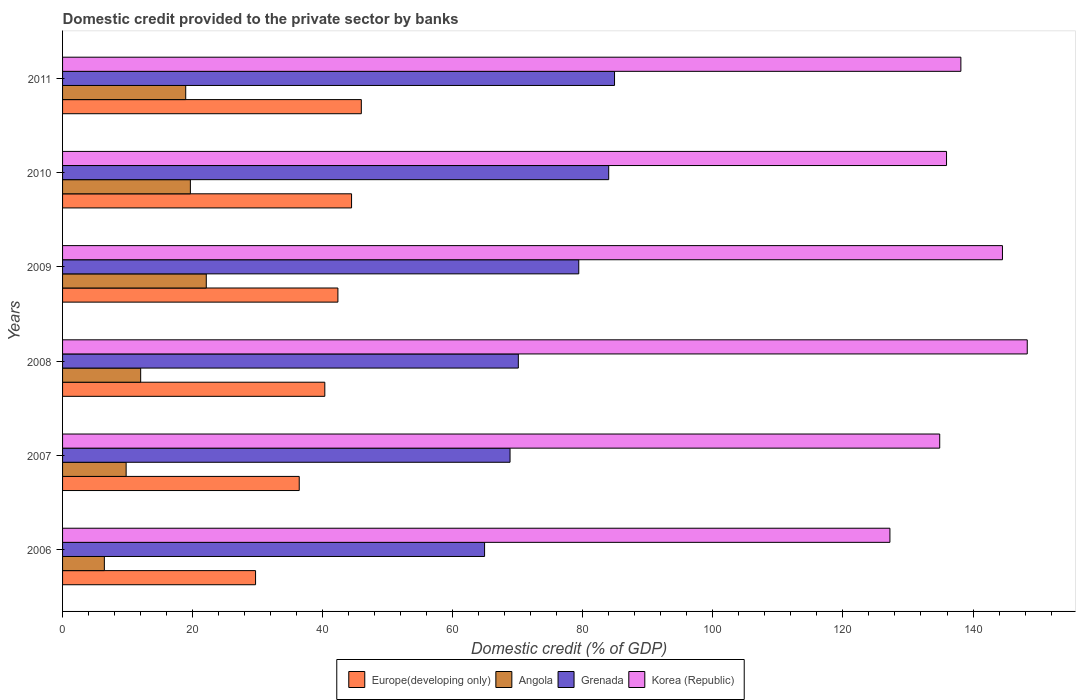How many different coloured bars are there?
Ensure brevity in your answer.  4. How many groups of bars are there?
Provide a succinct answer. 6. Are the number of bars per tick equal to the number of legend labels?
Your answer should be compact. Yes. How many bars are there on the 5th tick from the bottom?
Offer a very short reply. 4. What is the domestic credit provided to the private sector by banks in Korea (Republic) in 2006?
Provide a short and direct response. 127.22. Across all years, what is the maximum domestic credit provided to the private sector by banks in Grenada?
Provide a succinct answer. 84.88. Across all years, what is the minimum domestic credit provided to the private sector by banks in Europe(developing only)?
Your answer should be very brief. 29.68. In which year was the domestic credit provided to the private sector by banks in Korea (Republic) minimum?
Provide a short and direct response. 2006. What is the total domestic credit provided to the private sector by banks in Korea (Republic) in the graph?
Provide a short and direct response. 829.03. What is the difference between the domestic credit provided to the private sector by banks in Korea (Republic) in 2010 and that in 2011?
Your response must be concise. -2.21. What is the difference between the domestic credit provided to the private sector by banks in Grenada in 2010 and the domestic credit provided to the private sector by banks in Europe(developing only) in 2007?
Keep it short and to the point. 47.59. What is the average domestic credit provided to the private sector by banks in Korea (Republic) per year?
Give a very brief answer. 138.17. In the year 2007, what is the difference between the domestic credit provided to the private sector by banks in Korea (Republic) and domestic credit provided to the private sector by banks in Grenada?
Offer a very short reply. 66.07. What is the ratio of the domestic credit provided to the private sector by banks in Korea (Republic) in 2006 to that in 2007?
Give a very brief answer. 0.94. Is the difference between the domestic credit provided to the private sector by banks in Korea (Republic) in 2006 and 2008 greater than the difference between the domestic credit provided to the private sector by banks in Grenada in 2006 and 2008?
Provide a succinct answer. No. What is the difference between the highest and the second highest domestic credit provided to the private sector by banks in Angola?
Provide a short and direct response. 2.45. What is the difference between the highest and the lowest domestic credit provided to the private sector by banks in Angola?
Keep it short and to the point. 15.67. Is it the case that in every year, the sum of the domestic credit provided to the private sector by banks in Angola and domestic credit provided to the private sector by banks in Grenada is greater than the sum of domestic credit provided to the private sector by banks in Korea (Republic) and domestic credit provided to the private sector by banks in Europe(developing only)?
Your answer should be compact. No. What does the 2nd bar from the top in 2010 represents?
Your answer should be compact. Grenada. What does the 4th bar from the bottom in 2011 represents?
Offer a terse response. Korea (Republic). Is it the case that in every year, the sum of the domestic credit provided to the private sector by banks in Europe(developing only) and domestic credit provided to the private sector by banks in Angola is greater than the domestic credit provided to the private sector by banks in Korea (Republic)?
Give a very brief answer. No. How many bars are there?
Offer a very short reply. 24. How many years are there in the graph?
Provide a succinct answer. 6. What is the difference between two consecutive major ticks on the X-axis?
Offer a terse response. 20. Are the values on the major ticks of X-axis written in scientific E-notation?
Give a very brief answer. No. Does the graph contain any zero values?
Offer a very short reply. No. How many legend labels are there?
Give a very brief answer. 4. How are the legend labels stacked?
Offer a very short reply. Horizontal. What is the title of the graph?
Make the answer very short. Domestic credit provided to the private sector by banks. Does "Cote d'Ivoire" appear as one of the legend labels in the graph?
Your answer should be very brief. No. What is the label or title of the X-axis?
Make the answer very short. Domestic credit (% of GDP). What is the label or title of the Y-axis?
Offer a very short reply. Years. What is the Domestic credit (% of GDP) of Europe(developing only) in 2006?
Your answer should be compact. 29.68. What is the Domestic credit (% of GDP) of Angola in 2006?
Give a very brief answer. 6.43. What is the Domestic credit (% of GDP) of Grenada in 2006?
Your answer should be compact. 64.89. What is the Domestic credit (% of GDP) of Korea (Republic) in 2006?
Your answer should be very brief. 127.22. What is the Domestic credit (% of GDP) in Europe(developing only) in 2007?
Provide a short and direct response. 36.39. What is the Domestic credit (% of GDP) of Angola in 2007?
Offer a terse response. 9.77. What is the Domestic credit (% of GDP) of Grenada in 2007?
Provide a short and direct response. 68.81. What is the Domestic credit (% of GDP) in Korea (Republic) in 2007?
Make the answer very short. 134.88. What is the Domestic credit (% of GDP) of Europe(developing only) in 2008?
Provide a succinct answer. 40.32. What is the Domestic credit (% of GDP) in Angola in 2008?
Your answer should be very brief. 12.01. What is the Domestic credit (% of GDP) of Grenada in 2008?
Ensure brevity in your answer.  70.08. What is the Domestic credit (% of GDP) in Korea (Republic) in 2008?
Offer a very short reply. 148.34. What is the Domestic credit (% of GDP) in Europe(developing only) in 2009?
Offer a very short reply. 42.34. What is the Domestic credit (% of GDP) of Angola in 2009?
Give a very brief answer. 22.1. What is the Domestic credit (% of GDP) in Grenada in 2009?
Your response must be concise. 79.38. What is the Domestic credit (% of GDP) of Korea (Republic) in 2009?
Your answer should be compact. 144.53. What is the Domestic credit (% of GDP) of Europe(developing only) in 2010?
Give a very brief answer. 44.44. What is the Domestic credit (% of GDP) in Angola in 2010?
Ensure brevity in your answer.  19.65. What is the Domestic credit (% of GDP) in Grenada in 2010?
Your answer should be very brief. 83.98. What is the Domestic credit (% of GDP) of Korea (Republic) in 2010?
Offer a very short reply. 135.93. What is the Domestic credit (% of GDP) of Europe(developing only) in 2011?
Offer a very short reply. 45.94. What is the Domestic credit (% of GDP) of Angola in 2011?
Your response must be concise. 18.94. What is the Domestic credit (% of GDP) of Grenada in 2011?
Provide a succinct answer. 84.88. What is the Domestic credit (% of GDP) of Korea (Republic) in 2011?
Provide a short and direct response. 138.13. Across all years, what is the maximum Domestic credit (% of GDP) in Europe(developing only)?
Your response must be concise. 45.94. Across all years, what is the maximum Domestic credit (% of GDP) in Angola?
Your answer should be very brief. 22.1. Across all years, what is the maximum Domestic credit (% of GDP) in Grenada?
Your response must be concise. 84.88. Across all years, what is the maximum Domestic credit (% of GDP) of Korea (Republic)?
Give a very brief answer. 148.34. Across all years, what is the minimum Domestic credit (% of GDP) in Europe(developing only)?
Keep it short and to the point. 29.68. Across all years, what is the minimum Domestic credit (% of GDP) of Angola?
Your answer should be very brief. 6.43. Across all years, what is the minimum Domestic credit (% of GDP) in Grenada?
Keep it short and to the point. 64.89. Across all years, what is the minimum Domestic credit (% of GDP) of Korea (Republic)?
Make the answer very short. 127.22. What is the total Domestic credit (% of GDP) of Europe(developing only) in the graph?
Ensure brevity in your answer.  239.11. What is the total Domestic credit (% of GDP) in Angola in the graph?
Your answer should be compact. 88.9. What is the total Domestic credit (% of GDP) of Grenada in the graph?
Offer a terse response. 452.02. What is the total Domestic credit (% of GDP) of Korea (Republic) in the graph?
Your response must be concise. 829.03. What is the difference between the Domestic credit (% of GDP) of Europe(developing only) in 2006 and that in 2007?
Keep it short and to the point. -6.72. What is the difference between the Domestic credit (% of GDP) of Angola in 2006 and that in 2007?
Keep it short and to the point. -3.35. What is the difference between the Domestic credit (% of GDP) of Grenada in 2006 and that in 2007?
Offer a terse response. -3.91. What is the difference between the Domestic credit (% of GDP) of Korea (Republic) in 2006 and that in 2007?
Give a very brief answer. -7.66. What is the difference between the Domestic credit (% of GDP) in Europe(developing only) in 2006 and that in 2008?
Provide a short and direct response. -10.65. What is the difference between the Domestic credit (% of GDP) in Angola in 2006 and that in 2008?
Your answer should be compact. -5.58. What is the difference between the Domestic credit (% of GDP) of Grenada in 2006 and that in 2008?
Offer a very short reply. -5.19. What is the difference between the Domestic credit (% of GDP) in Korea (Republic) in 2006 and that in 2008?
Offer a terse response. -21.12. What is the difference between the Domestic credit (% of GDP) in Europe(developing only) in 2006 and that in 2009?
Your answer should be very brief. -12.66. What is the difference between the Domestic credit (% of GDP) of Angola in 2006 and that in 2009?
Your answer should be very brief. -15.67. What is the difference between the Domestic credit (% of GDP) in Grenada in 2006 and that in 2009?
Provide a succinct answer. -14.48. What is the difference between the Domestic credit (% of GDP) of Korea (Republic) in 2006 and that in 2009?
Make the answer very short. -17.31. What is the difference between the Domestic credit (% of GDP) of Europe(developing only) in 2006 and that in 2010?
Your answer should be compact. -14.76. What is the difference between the Domestic credit (% of GDP) in Angola in 2006 and that in 2010?
Provide a short and direct response. -13.23. What is the difference between the Domestic credit (% of GDP) in Grenada in 2006 and that in 2010?
Keep it short and to the point. -19.09. What is the difference between the Domestic credit (% of GDP) of Korea (Republic) in 2006 and that in 2010?
Offer a terse response. -8.71. What is the difference between the Domestic credit (% of GDP) of Europe(developing only) in 2006 and that in 2011?
Make the answer very short. -16.26. What is the difference between the Domestic credit (% of GDP) of Angola in 2006 and that in 2011?
Provide a short and direct response. -12.51. What is the difference between the Domestic credit (% of GDP) in Grenada in 2006 and that in 2011?
Make the answer very short. -19.98. What is the difference between the Domestic credit (% of GDP) in Korea (Republic) in 2006 and that in 2011?
Give a very brief answer. -10.91. What is the difference between the Domestic credit (% of GDP) of Europe(developing only) in 2007 and that in 2008?
Your answer should be very brief. -3.93. What is the difference between the Domestic credit (% of GDP) of Angola in 2007 and that in 2008?
Provide a succinct answer. -2.24. What is the difference between the Domestic credit (% of GDP) in Grenada in 2007 and that in 2008?
Your response must be concise. -1.27. What is the difference between the Domestic credit (% of GDP) in Korea (Republic) in 2007 and that in 2008?
Your answer should be very brief. -13.46. What is the difference between the Domestic credit (% of GDP) of Europe(developing only) in 2007 and that in 2009?
Keep it short and to the point. -5.95. What is the difference between the Domestic credit (% of GDP) in Angola in 2007 and that in 2009?
Your answer should be very brief. -12.32. What is the difference between the Domestic credit (% of GDP) in Grenada in 2007 and that in 2009?
Your answer should be very brief. -10.57. What is the difference between the Domestic credit (% of GDP) in Korea (Republic) in 2007 and that in 2009?
Your answer should be very brief. -9.65. What is the difference between the Domestic credit (% of GDP) in Europe(developing only) in 2007 and that in 2010?
Make the answer very short. -8.04. What is the difference between the Domestic credit (% of GDP) in Angola in 2007 and that in 2010?
Ensure brevity in your answer.  -9.88. What is the difference between the Domestic credit (% of GDP) of Grenada in 2007 and that in 2010?
Offer a very short reply. -15.17. What is the difference between the Domestic credit (% of GDP) in Korea (Republic) in 2007 and that in 2010?
Your response must be concise. -1.05. What is the difference between the Domestic credit (% of GDP) in Europe(developing only) in 2007 and that in 2011?
Offer a terse response. -9.55. What is the difference between the Domestic credit (% of GDP) of Angola in 2007 and that in 2011?
Your response must be concise. -9.16. What is the difference between the Domestic credit (% of GDP) in Grenada in 2007 and that in 2011?
Make the answer very short. -16.07. What is the difference between the Domestic credit (% of GDP) of Korea (Republic) in 2007 and that in 2011?
Offer a very short reply. -3.25. What is the difference between the Domestic credit (% of GDP) in Europe(developing only) in 2008 and that in 2009?
Provide a short and direct response. -2.01. What is the difference between the Domestic credit (% of GDP) in Angola in 2008 and that in 2009?
Give a very brief answer. -10.09. What is the difference between the Domestic credit (% of GDP) of Grenada in 2008 and that in 2009?
Provide a short and direct response. -9.3. What is the difference between the Domestic credit (% of GDP) in Korea (Republic) in 2008 and that in 2009?
Provide a short and direct response. 3.81. What is the difference between the Domestic credit (% of GDP) in Europe(developing only) in 2008 and that in 2010?
Your answer should be compact. -4.11. What is the difference between the Domestic credit (% of GDP) in Angola in 2008 and that in 2010?
Offer a terse response. -7.64. What is the difference between the Domestic credit (% of GDP) in Grenada in 2008 and that in 2010?
Ensure brevity in your answer.  -13.9. What is the difference between the Domestic credit (% of GDP) in Korea (Republic) in 2008 and that in 2010?
Offer a terse response. 12.41. What is the difference between the Domestic credit (% of GDP) of Europe(developing only) in 2008 and that in 2011?
Ensure brevity in your answer.  -5.62. What is the difference between the Domestic credit (% of GDP) in Angola in 2008 and that in 2011?
Your response must be concise. -6.93. What is the difference between the Domestic credit (% of GDP) in Grenada in 2008 and that in 2011?
Your answer should be compact. -14.8. What is the difference between the Domestic credit (% of GDP) of Korea (Republic) in 2008 and that in 2011?
Your response must be concise. 10.21. What is the difference between the Domestic credit (% of GDP) of Europe(developing only) in 2009 and that in 2010?
Keep it short and to the point. -2.1. What is the difference between the Domestic credit (% of GDP) in Angola in 2009 and that in 2010?
Provide a succinct answer. 2.45. What is the difference between the Domestic credit (% of GDP) in Grenada in 2009 and that in 2010?
Give a very brief answer. -4.6. What is the difference between the Domestic credit (% of GDP) in Korea (Republic) in 2009 and that in 2010?
Make the answer very short. 8.6. What is the difference between the Domestic credit (% of GDP) of Europe(developing only) in 2009 and that in 2011?
Make the answer very short. -3.6. What is the difference between the Domestic credit (% of GDP) of Angola in 2009 and that in 2011?
Offer a terse response. 3.16. What is the difference between the Domestic credit (% of GDP) in Grenada in 2009 and that in 2011?
Your answer should be compact. -5.5. What is the difference between the Domestic credit (% of GDP) in Korea (Republic) in 2009 and that in 2011?
Make the answer very short. 6.39. What is the difference between the Domestic credit (% of GDP) of Europe(developing only) in 2010 and that in 2011?
Your answer should be very brief. -1.5. What is the difference between the Domestic credit (% of GDP) of Angola in 2010 and that in 2011?
Offer a terse response. 0.72. What is the difference between the Domestic credit (% of GDP) of Grenada in 2010 and that in 2011?
Make the answer very short. -0.9. What is the difference between the Domestic credit (% of GDP) in Korea (Republic) in 2010 and that in 2011?
Offer a terse response. -2.21. What is the difference between the Domestic credit (% of GDP) of Europe(developing only) in 2006 and the Domestic credit (% of GDP) of Angola in 2007?
Your answer should be very brief. 19.9. What is the difference between the Domestic credit (% of GDP) in Europe(developing only) in 2006 and the Domestic credit (% of GDP) in Grenada in 2007?
Your response must be concise. -39.13. What is the difference between the Domestic credit (% of GDP) of Europe(developing only) in 2006 and the Domestic credit (% of GDP) of Korea (Republic) in 2007?
Provide a short and direct response. -105.2. What is the difference between the Domestic credit (% of GDP) in Angola in 2006 and the Domestic credit (% of GDP) in Grenada in 2007?
Provide a short and direct response. -62.38. What is the difference between the Domestic credit (% of GDP) of Angola in 2006 and the Domestic credit (% of GDP) of Korea (Republic) in 2007?
Offer a terse response. -128.45. What is the difference between the Domestic credit (% of GDP) of Grenada in 2006 and the Domestic credit (% of GDP) of Korea (Republic) in 2007?
Offer a terse response. -69.99. What is the difference between the Domestic credit (% of GDP) of Europe(developing only) in 2006 and the Domestic credit (% of GDP) of Angola in 2008?
Ensure brevity in your answer.  17.67. What is the difference between the Domestic credit (% of GDP) in Europe(developing only) in 2006 and the Domestic credit (% of GDP) in Grenada in 2008?
Your answer should be very brief. -40.4. What is the difference between the Domestic credit (% of GDP) in Europe(developing only) in 2006 and the Domestic credit (% of GDP) in Korea (Republic) in 2008?
Your answer should be compact. -118.66. What is the difference between the Domestic credit (% of GDP) of Angola in 2006 and the Domestic credit (% of GDP) of Grenada in 2008?
Provide a short and direct response. -63.66. What is the difference between the Domestic credit (% of GDP) in Angola in 2006 and the Domestic credit (% of GDP) in Korea (Republic) in 2008?
Provide a succinct answer. -141.91. What is the difference between the Domestic credit (% of GDP) of Grenada in 2006 and the Domestic credit (% of GDP) of Korea (Republic) in 2008?
Keep it short and to the point. -83.45. What is the difference between the Domestic credit (% of GDP) of Europe(developing only) in 2006 and the Domestic credit (% of GDP) of Angola in 2009?
Make the answer very short. 7.58. What is the difference between the Domestic credit (% of GDP) of Europe(developing only) in 2006 and the Domestic credit (% of GDP) of Grenada in 2009?
Offer a very short reply. -49.7. What is the difference between the Domestic credit (% of GDP) of Europe(developing only) in 2006 and the Domestic credit (% of GDP) of Korea (Republic) in 2009?
Offer a very short reply. -114.85. What is the difference between the Domestic credit (% of GDP) of Angola in 2006 and the Domestic credit (% of GDP) of Grenada in 2009?
Provide a succinct answer. -72.95. What is the difference between the Domestic credit (% of GDP) of Angola in 2006 and the Domestic credit (% of GDP) of Korea (Republic) in 2009?
Offer a terse response. -138.1. What is the difference between the Domestic credit (% of GDP) of Grenada in 2006 and the Domestic credit (% of GDP) of Korea (Republic) in 2009?
Offer a terse response. -79.63. What is the difference between the Domestic credit (% of GDP) of Europe(developing only) in 2006 and the Domestic credit (% of GDP) of Angola in 2010?
Provide a short and direct response. 10.02. What is the difference between the Domestic credit (% of GDP) in Europe(developing only) in 2006 and the Domestic credit (% of GDP) in Grenada in 2010?
Your answer should be very brief. -54.3. What is the difference between the Domestic credit (% of GDP) in Europe(developing only) in 2006 and the Domestic credit (% of GDP) in Korea (Republic) in 2010?
Your response must be concise. -106.25. What is the difference between the Domestic credit (% of GDP) of Angola in 2006 and the Domestic credit (% of GDP) of Grenada in 2010?
Your answer should be compact. -77.55. What is the difference between the Domestic credit (% of GDP) in Angola in 2006 and the Domestic credit (% of GDP) in Korea (Republic) in 2010?
Ensure brevity in your answer.  -129.5. What is the difference between the Domestic credit (% of GDP) of Grenada in 2006 and the Domestic credit (% of GDP) of Korea (Republic) in 2010?
Offer a very short reply. -71.03. What is the difference between the Domestic credit (% of GDP) of Europe(developing only) in 2006 and the Domestic credit (% of GDP) of Angola in 2011?
Your response must be concise. 10.74. What is the difference between the Domestic credit (% of GDP) in Europe(developing only) in 2006 and the Domestic credit (% of GDP) in Grenada in 2011?
Offer a terse response. -55.2. What is the difference between the Domestic credit (% of GDP) in Europe(developing only) in 2006 and the Domestic credit (% of GDP) in Korea (Republic) in 2011?
Ensure brevity in your answer.  -108.46. What is the difference between the Domestic credit (% of GDP) of Angola in 2006 and the Domestic credit (% of GDP) of Grenada in 2011?
Ensure brevity in your answer.  -78.45. What is the difference between the Domestic credit (% of GDP) of Angola in 2006 and the Domestic credit (% of GDP) of Korea (Republic) in 2011?
Offer a very short reply. -131.71. What is the difference between the Domestic credit (% of GDP) of Grenada in 2006 and the Domestic credit (% of GDP) of Korea (Republic) in 2011?
Provide a short and direct response. -73.24. What is the difference between the Domestic credit (% of GDP) of Europe(developing only) in 2007 and the Domestic credit (% of GDP) of Angola in 2008?
Keep it short and to the point. 24.38. What is the difference between the Domestic credit (% of GDP) of Europe(developing only) in 2007 and the Domestic credit (% of GDP) of Grenada in 2008?
Offer a terse response. -33.69. What is the difference between the Domestic credit (% of GDP) of Europe(developing only) in 2007 and the Domestic credit (% of GDP) of Korea (Republic) in 2008?
Keep it short and to the point. -111.95. What is the difference between the Domestic credit (% of GDP) in Angola in 2007 and the Domestic credit (% of GDP) in Grenada in 2008?
Make the answer very short. -60.31. What is the difference between the Domestic credit (% of GDP) in Angola in 2007 and the Domestic credit (% of GDP) in Korea (Republic) in 2008?
Your answer should be compact. -138.57. What is the difference between the Domestic credit (% of GDP) of Grenada in 2007 and the Domestic credit (% of GDP) of Korea (Republic) in 2008?
Your answer should be very brief. -79.53. What is the difference between the Domestic credit (% of GDP) of Europe(developing only) in 2007 and the Domestic credit (% of GDP) of Angola in 2009?
Ensure brevity in your answer.  14.29. What is the difference between the Domestic credit (% of GDP) in Europe(developing only) in 2007 and the Domestic credit (% of GDP) in Grenada in 2009?
Keep it short and to the point. -42.98. What is the difference between the Domestic credit (% of GDP) of Europe(developing only) in 2007 and the Domestic credit (% of GDP) of Korea (Republic) in 2009?
Provide a short and direct response. -108.13. What is the difference between the Domestic credit (% of GDP) in Angola in 2007 and the Domestic credit (% of GDP) in Grenada in 2009?
Keep it short and to the point. -69.6. What is the difference between the Domestic credit (% of GDP) of Angola in 2007 and the Domestic credit (% of GDP) of Korea (Republic) in 2009?
Offer a very short reply. -134.75. What is the difference between the Domestic credit (% of GDP) of Grenada in 2007 and the Domestic credit (% of GDP) of Korea (Republic) in 2009?
Offer a terse response. -75.72. What is the difference between the Domestic credit (% of GDP) of Europe(developing only) in 2007 and the Domestic credit (% of GDP) of Angola in 2010?
Provide a succinct answer. 16.74. What is the difference between the Domestic credit (% of GDP) in Europe(developing only) in 2007 and the Domestic credit (% of GDP) in Grenada in 2010?
Keep it short and to the point. -47.59. What is the difference between the Domestic credit (% of GDP) of Europe(developing only) in 2007 and the Domestic credit (% of GDP) of Korea (Republic) in 2010?
Your response must be concise. -99.53. What is the difference between the Domestic credit (% of GDP) of Angola in 2007 and the Domestic credit (% of GDP) of Grenada in 2010?
Ensure brevity in your answer.  -74.21. What is the difference between the Domestic credit (% of GDP) in Angola in 2007 and the Domestic credit (% of GDP) in Korea (Republic) in 2010?
Give a very brief answer. -126.15. What is the difference between the Domestic credit (% of GDP) of Grenada in 2007 and the Domestic credit (% of GDP) of Korea (Republic) in 2010?
Your answer should be compact. -67.12. What is the difference between the Domestic credit (% of GDP) in Europe(developing only) in 2007 and the Domestic credit (% of GDP) in Angola in 2011?
Your response must be concise. 17.46. What is the difference between the Domestic credit (% of GDP) of Europe(developing only) in 2007 and the Domestic credit (% of GDP) of Grenada in 2011?
Your answer should be compact. -48.48. What is the difference between the Domestic credit (% of GDP) in Europe(developing only) in 2007 and the Domestic credit (% of GDP) in Korea (Republic) in 2011?
Offer a very short reply. -101.74. What is the difference between the Domestic credit (% of GDP) in Angola in 2007 and the Domestic credit (% of GDP) in Grenada in 2011?
Offer a terse response. -75.1. What is the difference between the Domestic credit (% of GDP) in Angola in 2007 and the Domestic credit (% of GDP) in Korea (Republic) in 2011?
Offer a very short reply. -128.36. What is the difference between the Domestic credit (% of GDP) of Grenada in 2007 and the Domestic credit (% of GDP) of Korea (Republic) in 2011?
Your answer should be compact. -69.32. What is the difference between the Domestic credit (% of GDP) in Europe(developing only) in 2008 and the Domestic credit (% of GDP) in Angola in 2009?
Ensure brevity in your answer.  18.22. What is the difference between the Domestic credit (% of GDP) of Europe(developing only) in 2008 and the Domestic credit (% of GDP) of Grenada in 2009?
Give a very brief answer. -39.05. What is the difference between the Domestic credit (% of GDP) of Europe(developing only) in 2008 and the Domestic credit (% of GDP) of Korea (Republic) in 2009?
Your answer should be compact. -104.2. What is the difference between the Domestic credit (% of GDP) in Angola in 2008 and the Domestic credit (% of GDP) in Grenada in 2009?
Make the answer very short. -67.37. What is the difference between the Domestic credit (% of GDP) in Angola in 2008 and the Domestic credit (% of GDP) in Korea (Republic) in 2009?
Keep it short and to the point. -132.52. What is the difference between the Domestic credit (% of GDP) of Grenada in 2008 and the Domestic credit (% of GDP) of Korea (Republic) in 2009?
Make the answer very short. -74.45. What is the difference between the Domestic credit (% of GDP) of Europe(developing only) in 2008 and the Domestic credit (% of GDP) of Angola in 2010?
Keep it short and to the point. 20.67. What is the difference between the Domestic credit (% of GDP) in Europe(developing only) in 2008 and the Domestic credit (% of GDP) in Grenada in 2010?
Your answer should be very brief. -43.66. What is the difference between the Domestic credit (% of GDP) in Europe(developing only) in 2008 and the Domestic credit (% of GDP) in Korea (Republic) in 2010?
Provide a short and direct response. -95.6. What is the difference between the Domestic credit (% of GDP) in Angola in 2008 and the Domestic credit (% of GDP) in Grenada in 2010?
Ensure brevity in your answer.  -71.97. What is the difference between the Domestic credit (% of GDP) of Angola in 2008 and the Domestic credit (% of GDP) of Korea (Republic) in 2010?
Your response must be concise. -123.92. What is the difference between the Domestic credit (% of GDP) in Grenada in 2008 and the Domestic credit (% of GDP) in Korea (Republic) in 2010?
Ensure brevity in your answer.  -65.85. What is the difference between the Domestic credit (% of GDP) in Europe(developing only) in 2008 and the Domestic credit (% of GDP) in Angola in 2011?
Your answer should be compact. 21.39. What is the difference between the Domestic credit (% of GDP) in Europe(developing only) in 2008 and the Domestic credit (% of GDP) in Grenada in 2011?
Ensure brevity in your answer.  -44.55. What is the difference between the Domestic credit (% of GDP) in Europe(developing only) in 2008 and the Domestic credit (% of GDP) in Korea (Republic) in 2011?
Your answer should be compact. -97.81. What is the difference between the Domestic credit (% of GDP) of Angola in 2008 and the Domestic credit (% of GDP) of Grenada in 2011?
Keep it short and to the point. -72.87. What is the difference between the Domestic credit (% of GDP) in Angola in 2008 and the Domestic credit (% of GDP) in Korea (Republic) in 2011?
Keep it short and to the point. -126.12. What is the difference between the Domestic credit (% of GDP) of Grenada in 2008 and the Domestic credit (% of GDP) of Korea (Republic) in 2011?
Offer a very short reply. -68.05. What is the difference between the Domestic credit (% of GDP) in Europe(developing only) in 2009 and the Domestic credit (% of GDP) in Angola in 2010?
Your answer should be compact. 22.69. What is the difference between the Domestic credit (% of GDP) in Europe(developing only) in 2009 and the Domestic credit (% of GDP) in Grenada in 2010?
Ensure brevity in your answer.  -41.64. What is the difference between the Domestic credit (% of GDP) of Europe(developing only) in 2009 and the Domestic credit (% of GDP) of Korea (Republic) in 2010?
Give a very brief answer. -93.59. What is the difference between the Domestic credit (% of GDP) of Angola in 2009 and the Domestic credit (% of GDP) of Grenada in 2010?
Ensure brevity in your answer.  -61.88. What is the difference between the Domestic credit (% of GDP) of Angola in 2009 and the Domestic credit (% of GDP) of Korea (Republic) in 2010?
Your answer should be very brief. -113.83. What is the difference between the Domestic credit (% of GDP) in Grenada in 2009 and the Domestic credit (% of GDP) in Korea (Republic) in 2010?
Provide a short and direct response. -56.55. What is the difference between the Domestic credit (% of GDP) in Europe(developing only) in 2009 and the Domestic credit (% of GDP) in Angola in 2011?
Provide a succinct answer. 23.4. What is the difference between the Domestic credit (% of GDP) in Europe(developing only) in 2009 and the Domestic credit (% of GDP) in Grenada in 2011?
Offer a very short reply. -42.54. What is the difference between the Domestic credit (% of GDP) in Europe(developing only) in 2009 and the Domestic credit (% of GDP) in Korea (Republic) in 2011?
Your response must be concise. -95.79. What is the difference between the Domestic credit (% of GDP) of Angola in 2009 and the Domestic credit (% of GDP) of Grenada in 2011?
Provide a succinct answer. -62.78. What is the difference between the Domestic credit (% of GDP) in Angola in 2009 and the Domestic credit (% of GDP) in Korea (Republic) in 2011?
Ensure brevity in your answer.  -116.03. What is the difference between the Domestic credit (% of GDP) of Grenada in 2009 and the Domestic credit (% of GDP) of Korea (Republic) in 2011?
Make the answer very short. -58.76. What is the difference between the Domestic credit (% of GDP) of Europe(developing only) in 2010 and the Domestic credit (% of GDP) of Angola in 2011?
Your answer should be compact. 25.5. What is the difference between the Domestic credit (% of GDP) of Europe(developing only) in 2010 and the Domestic credit (% of GDP) of Grenada in 2011?
Your response must be concise. -40.44. What is the difference between the Domestic credit (% of GDP) of Europe(developing only) in 2010 and the Domestic credit (% of GDP) of Korea (Republic) in 2011?
Ensure brevity in your answer.  -93.7. What is the difference between the Domestic credit (% of GDP) of Angola in 2010 and the Domestic credit (% of GDP) of Grenada in 2011?
Offer a very short reply. -65.22. What is the difference between the Domestic credit (% of GDP) in Angola in 2010 and the Domestic credit (% of GDP) in Korea (Republic) in 2011?
Offer a terse response. -118.48. What is the difference between the Domestic credit (% of GDP) of Grenada in 2010 and the Domestic credit (% of GDP) of Korea (Republic) in 2011?
Provide a short and direct response. -54.15. What is the average Domestic credit (% of GDP) in Europe(developing only) per year?
Your response must be concise. 39.85. What is the average Domestic credit (% of GDP) of Angola per year?
Your answer should be compact. 14.82. What is the average Domestic credit (% of GDP) in Grenada per year?
Keep it short and to the point. 75.34. What is the average Domestic credit (% of GDP) of Korea (Republic) per year?
Ensure brevity in your answer.  138.17. In the year 2006, what is the difference between the Domestic credit (% of GDP) of Europe(developing only) and Domestic credit (% of GDP) of Angola?
Offer a terse response. 23.25. In the year 2006, what is the difference between the Domestic credit (% of GDP) of Europe(developing only) and Domestic credit (% of GDP) of Grenada?
Give a very brief answer. -35.22. In the year 2006, what is the difference between the Domestic credit (% of GDP) of Europe(developing only) and Domestic credit (% of GDP) of Korea (Republic)?
Ensure brevity in your answer.  -97.54. In the year 2006, what is the difference between the Domestic credit (% of GDP) of Angola and Domestic credit (% of GDP) of Grenada?
Your response must be concise. -58.47. In the year 2006, what is the difference between the Domestic credit (% of GDP) of Angola and Domestic credit (% of GDP) of Korea (Republic)?
Provide a succinct answer. -120.8. In the year 2006, what is the difference between the Domestic credit (% of GDP) of Grenada and Domestic credit (% of GDP) of Korea (Republic)?
Ensure brevity in your answer.  -62.33. In the year 2007, what is the difference between the Domestic credit (% of GDP) in Europe(developing only) and Domestic credit (% of GDP) in Angola?
Provide a short and direct response. 26.62. In the year 2007, what is the difference between the Domestic credit (% of GDP) in Europe(developing only) and Domestic credit (% of GDP) in Grenada?
Offer a very short reply. -32.41. In the year 2007, what is the difference between the Domestic credit (% of GDP) in Europe(developing only) and Domestic credit (% of GDP) in Korea (Republic)?
Make the answer very short. -98.49. In the year 2007, what is the difference between the Domestic credit (% of GDP) of Angola and Domestic credit (% of GDP) of Grenada?
Your answer should be compact. -59.03. In the year 2007, what is the difference between the Domestic credit (% of GDP) in Angola and Domestic credit (% of GDP) in Korea (Republic)?
Your response must be concise. -125.11. In the year 2007, what is the difference between the Domestic credit (% of GDP) of Grenada and Domestic credit (% of GDP) of Korea (Republic)?
Provide a succinct answer. -66.07. In the year 2008, what is the difference between the Domestic credit (% of GDP) in Europe(developing only) and Domestic credit (% of GDP) in Angola?
Your answer should be very brief. 28.31. In the year 2008, what is the difference between the Domestic credit (% of GDP) of Europe(developing only) and Domestic credit (% of GDP) of Grenada?
Offer a terse response. -29.76. In the year 2008, what is the difference between the Domestic credit (% of GDP) of Europe(developing only) and Domestic credit (% of GDP) of Korea (Republic)?
Make the answer very short. -108.02. In the year 2008, what is the difference between the Domestic credit (% of GDP) in Angola and Domestic credit (% of GDP) in Grenada?
Your answer should be compact. -58.07. In the year 2008, what is the difference between the Domestic credit (% of GDP) in Angola and Domestic credit (% of GDP) in Korea (Republic)?
Your answer should be compact. -136.33. In the year 2008, what is the difference between the Domestic credit (% of GDP) in Grenada and Domestic credit (% of GDP) in Korea (Republic)?
Offer a very short reply. -78.26. In the year 2009, what is the difference between the Domestic credit (% of GDP) in Europe(developing only) and Domestic credit (% of GDP) in Angola?
Offer a terse response. 20.24. In the year 2009, what is the difference between the Domestic credit (% of GDP) in Europe(developing only) and Domestic credit (% of GDP) in Grenada?
Keep it short and to the point. -37.04. In the year 2009, what is the difference between the Domestic credit (% of GDP) of Europe(developing only) and Domestic credit (% of GDP) of Korea (Republic)?
Keep it short and to the point. -102.19. In the year 2009, what is the difference between the Domestic credit (% of GDP) in Angola and Domestic credit (% of GDP) in Grenada?
Provide a short and direct response. -57.28. In the year 2009, what is the difference between the Domestic credit (% of GDP) of Angola and Domestic credit (% of GDP) of Korea (Republic)?
Keep it short and to the point. -122.43. In the year 2009, what is the difference between the Domestic credit (% of GDP) in Grenada and Domestic credit (% of GDP) in Korea (Republic)?
Your response must be concise. -65.15. In the year 2010, what is the difference between the Domestic credit (% of GDP) of Europe(developing only) and Domestic credit (% of GDP) of Angola?
Your response must be concise. 24.78. In the year 2010, what is the difference between the Domestic credit (% of GDP) of Europe(developing only) and Domestic credit (% of GDP) of Grenada?
Provide a short and direct response. -39.54. In the year 2010, what is the difference between the Domestic credit (% of GDP) of Europe(developing only) and Domestic credit (% of GDP) of Korea (Republic)?
Provide a short and direct response. -91.49. In the year 2010, what is the difference between the Domestic credit (% of GDP) in Angola and Domestic credit (% of GDP) in Grenada?
Ensure brevity in your answer.  -64.33. In the year 2010, what is the difference between the Domestic credit (% of GDP) in Angola and Domestic credit (% of GDP) in Korea (Republic)?
Your answer should be very brief. -116.27. In the year 2010, what is the difference between the Domestic credit (% of GDP) of Grenada and Domestic credit (% of GDP) of Korea (Republic)?
Give a very brief answer. -51.95. In the year 2011, what is the difference between the Domestic credit (% of GDP) of Europe(developing only) and Domestic credit (% of GDP) of Angola?
Your answer should be very brief. 27. In the year 2011, what is the difference between the Domestic credit (% of GDP) of Europe(developing only) and Domestic credit (% of GDP) of Grenada?
Provide a succinct answer. -38.94. In the year 2011, what is the difference between the Domestic credit (% of GDP) in Europe(developing only) and Domestic credit (% of GDP) in Korea (Republic)?
Offer a terse response. -92.19. In the year 2011, what is the difference between the Domestic credit (% of GDP) of Angola and Domestic credit (% of GDP) of Grenada?
Keep it short and to the point. -65.94. In the year 2011, what is the difference between the Domestic credit (% of GDP) in Angola and Domestic credit (% of GDP) in Korea (Republic)?
Your answer should be very brief. -119.2. In the year 2011, what is the difference between the Domestic credit (% of GDP) of Grenada and Domestic credit (% of GDP) of Korea (Republic)?
Your response must be concise. -53.26. What is the ratio of the Domestic credit (% of GDP) of Europe(developing only) in 2006 to that in 2007?
Provide a succinct answer. 0.82. What is the ratio of the Domestic credit (% of GDP) of Angola in 2006 to that in 2007?
Your answer should be very brief. 0.66. What is the ratio of the Domestic credit (% of GDP) in Grenada in 2006 to that in 2007?
Your answer should be very brief. 0.94. What is the ratio of the Domestic credit (% of GDP) of Korea (Republic) in 2006 to that in 2007?
Ensure brevity in your answer.  0.94. What is the ratio of the Domestic credit (% of GDP) of Europe(developing only) in 2006 to that in 2008?
Offer a terse response. 0.74. What is the ratio of the Domestic credit (% of GDP) of Angola in 2006 to that in 2008?
Give a very brief answer. 0.54. What is the ratio of the Domestic credit (% of GDP) in Grenada in 2006 to that in 2008?
Ensure brevity in your answer.  0.93. What is the ratio of the Domestic credit (% of GDP) in Korea (Republic) in 2006 to that in 2008?
Your answer should be very brief. 0.86. What is the ratio of the Domestic credit (% of GDP) in Europe(developing only) in 2006 to that in 2009?
Give a very brief answer. 0.7. What is the ratio of the Domestic credit (% of GDP) of Angola in 2006 to that in 2009?
Give a very brief answer. 0.29. What is the ratio of the Domestic credit (% of GDP) of Grenada in 2006 to that in 2009?
Provide a succinct answer. 0.82. What is the ratio of the Domestic credit (% of GDP) of Korea (Republic) in 2006 to that in 2009?
Your response must be concise. 0.88. What is the ratio of the Domestic credit (% of GDP) of Europe(developing only) in 2006 to that in 2010?
Make the answer very short. 0.67. What is the ratio of the Domestic credit (% of GDP) of Angola in 2006 to that in 2010?
Offer a terse response. 0.33. What is the ratio of the Domestic credit (% of GDP) of Grenada in 2006 to that in 2010?
Offer a terse response. 0.77. What is the ratio of the Domestic credit (% of GDP) of Korea (Republic) in 2006 to that in 2010?
Your answer should be very brief. 0.94. What is the ratio of the Domestic credit (% of GDP) in Europe(developing only) in 2006 to that in 2011?
Keep it short and to the point. 0.65. What is the ratio of the Domestic credit (% of GDP) of Angola in 2006 to that in 2011?
Provide a succinct answer. 0.34. What is the ratio of the Domestic credit (% of GDP) in Grenada in 2006 to that in 2011?
Your answer should be compact. 0.76. What is the ratio of the Domestic credit (% of GDP) of Korea (Republic) in 2006 to that in 2011?
Keep it short and to the point. 0.92. What is the ratio of the Domestic credit (% of GDP) of Europe(developing only) in 2007 to that in 2008?
Your answer should be very brief. 0.9. What is the ratio of the Domestic credit (% of GDP) in Angola in 2007 to that in 2008?
Your response must be concise. 0.81. What is the ratio of the Domestic credit (% of GDP) of Grenada in 2007 to that in 2008?
Your answer should be very brief. 0.98. What is the ratio of the Domestic credit (% of GDP) of Korea (Republic) in 2007 to that in 2008?
Offer a terse response. 0.91. What is the ratio of the Domestic credit (% of GDP) in Europe(developing only) in 2007 to that in 2009?
Offer a terse response. 0.86. What is the ratio of the Domestic credit (% of GDP) in Angola in 2007 to that in 2009?
Offer a very short reply. 0.44. What is the ratio of the Domestic credit (% of GDP) in Grenada in 2007 to that in 2009?
Give a very brief answer. 0.87. What is the ratio of the Domestic credit (% of GDP) in Korea (Republic) in 2007 to that in 2009?
Provide a short and direct response. 0.93. What is the ratio of the Domestic credit (% of GDP) in Europe(developing only) in 2007 to that in 2010?
Your answer should be compact. 0.82. What is the ratio of the Domestic credit (% of GDP) in Angola in 2007 to that in 2010?
Provide a short and direct response. 0.5. What is the ratio of the Domestic credit (% of GDP) of Grenada in 2007 to that in 2010?
Provide a succinct answer. 0.82. What is the ratio of the Domestic credit (% of GDP) of Korea (Republic) in 2007 to that in 2010?
Ensure brevity in your answer.  0.99. What is the ratio of the Domestic credit (% of GDP) in Europe(developing only) in 2007 to that in 2011?
Provide a short and direct response. 0.79. What is the ratio of the Domestic credit (% of GDP) in Angola in 2007 to that in 2011?
Keep it short and to the point. 0.52. What is the ratio of the Domestic credit (% of GDP) of Grenada in 2007 to that in 2011?
Ensure brevity in your answer.  0.81. What is the ratio of the Domestic credit (% of GDP) in Korea (Republic) in 2007 to that in 2011?
Provide a succinct answer. 0.98. What is the ratio of the Domestic credit (% of GDP) in Europe(developing only) in 2008 to that in 2009?
Give a very brief answer. 0.95. What is the ratio of the Domestic credit (% of GDP) of Angola in 2008 to that in 2009?
Provide a succinct answer. 0.54. What is the ratio of the Domestic credit (% of GDP) in Grenada in 2008 to that in 2009?
Provide a succinct answer. 0.88. What is the ratio of the Domestic credit (% of GDP) in Korea (Republic) in 2008 to that in 2009?
Your response must be concise. 1.03. What is the ratio of the Domestic credit (% of GDP) of Europe(developing only) in 2008 to that in 2010?
Give a very brief answer. 0.91. What is the ratio of the Domestic credit (% of GDP) in Angola in 2008 to that in 2010?
Your response must be concise. 0.61. What is the ratio of the Domestic credit (% of GDP) in Grenada in 2008 to that in 2010?
Offer a very short reply. 0.83. What is the ratio of the Domestic credit (% of GDP) in Korea (Republic) in 2008 to that in 2010?
Ensure brevity in your answer.  1.09. What is the ratio of the Domestic credit (% of GDP) in Europe(developing only) in 2008 to that in 2011?
Your answer should be very brief. 0.88. What is the ratio of the Domestic credit (% of GDP) of Angola in 2008 to that in 2011?
Make the answer very short. 0.63. What is the ratio of the Domestic credit (% of GDP) of Grenada in 2008 to that in 2011?
Keep it short and to the point. 0.83. What is the ratio of the Domestic credit (% of GDP) of Korea (Republic) in 2008 to that in 2011?
Your answer should be compact. 1.07. What is the ratio of the Domestic credit (% of GDP) of Europe(developing only) in 2009 to that in 2010?
Keep it short and to the point. 0.95. What is the ratio of the Domestic credit (% of GDP) of Angola in 2009 to that in 2010?
Your answer should be compact. 1.12. What is the ratio of the Domestic credit (% of GDP) of Grenada in 2009 to that in 2010?
Give a very brief answer. 0.95. What is the ratio of the Domestic credit (% of GDP) in Korea (Republic) in 2009 to that in 2010?
Provide a succinct answer. 1.06. What is the ratio of the Domestic credit (% of GDP) of Europe(developing only) in 2009 to that in 2011?
Give a very brief answer. 0.92. What is the ratio of the Domestic credit (% of GDP) in Angola in 2009 to that in 2011?
Your response must be concise. 1.17. What is the ratio of the Domestic credit (% of GDP) of Grenada in 2009 to that in 2011?
Offer a terse response. 0.94. What is the ratio of the Domestic credit (% of GDP) of Korea (Republic) in 2009 to that in 2011?
Ensure brevity in your answer.  1.05. What is the ratio of the Domestic credit (% of GDP) in Europe(developing only) in 2010 to that in 2011?
Make the answer very short. 0.97. What is the ratio of the Domestic credit (% of GDP) of Angola in 2010 to that in 2011?
Your answer should be very brief. 1.04. What is the ratio of the Domestic credit (% of GDP) in Korea (Republic) in 2010 to that in 2011?
Your answer should be compact. 0.98. What is the difference between the highest and the second highest Domestic credit (% of GDP) of Europe(developing only)?
Provide a succinct answer. 1.5. What is the difference between the highest and the second highest Domestic credit (% of GDP) of Angola?
Give a very brief answer. 2.45. What is the difference between the highest and the second highest Domestic credit (% of GDP) of Grenada?
Provide a short and direct response. 0.9. What is the difference between the highest and the second highest Domestic credit (% of GDP) in Korea (Republic)?
Your answer should be compact. 3.81. What is the difference between the highest and the lowest Domestic credit (% of GDP) of Europe(developing only)?
Provide a succinct answer. 16.26. What is the difference between the highest and the lowest Domestic credit (% of GDP) of Angola?
Ensure brevity in your answer.  15.67. What is the difference between the highest and the lowest Domestic credit (% of GDP) in Grenada?
Your answer should be very brief. 19.98. What is the difference between the highest and the lowest Domestic credit (% of GDP) in Korea (Republic)?
Provide a succinct answer. 21.12. 